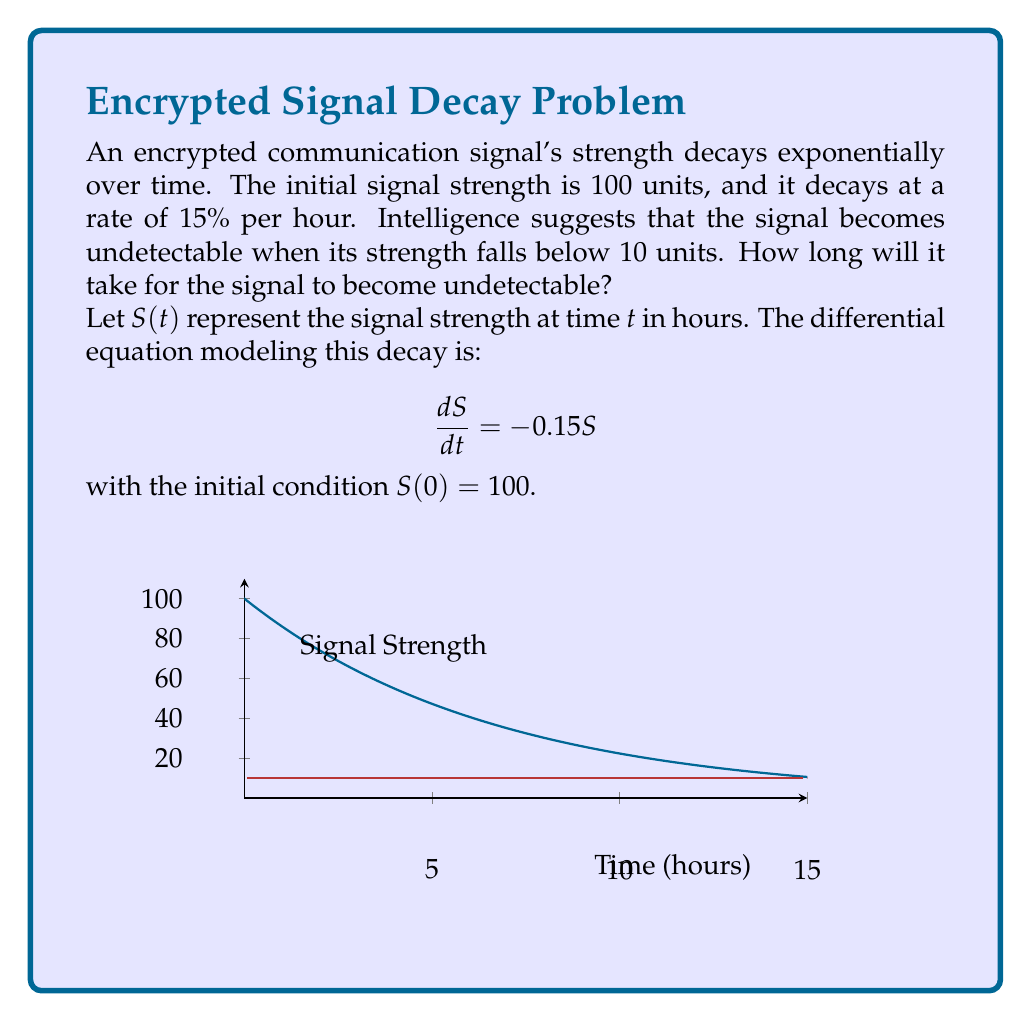Could you help me with this problem? To solve this problem, we follow these steps:

1) The general solution to the differential equation $\frac{dS}{dt} = -0.15S$ is:
   
   $S(t) = Ce^{-0.15t}$

2) Using the initial condition $S(0) = 100$, we can find $C$:
   
   $100 = Ce^{-0.15(0)}$
   $100 = C$

3) Thus, our specific solution is:
   
   $S(t) = 100e^{-0.15t}$

4) We want to find $t$ when $S(t) = 10$:
   
   $10 = 100e^{-0.15t}$

5) Dividing both sides by 100:
   
   $0.1 = e^{-0.15t}$

6) Taking the natural logarithm of both sides:
   
   $\ln(0.1) = -0.15t$

7) Solving for $t$:
   
   $t = \frac{\ln(0.1)}{-0.15} \approx 15.33$ hours

Therefore, it will take approximately 15.33 hours for the signal to become undetectable.
Answer: 15.33 hours 